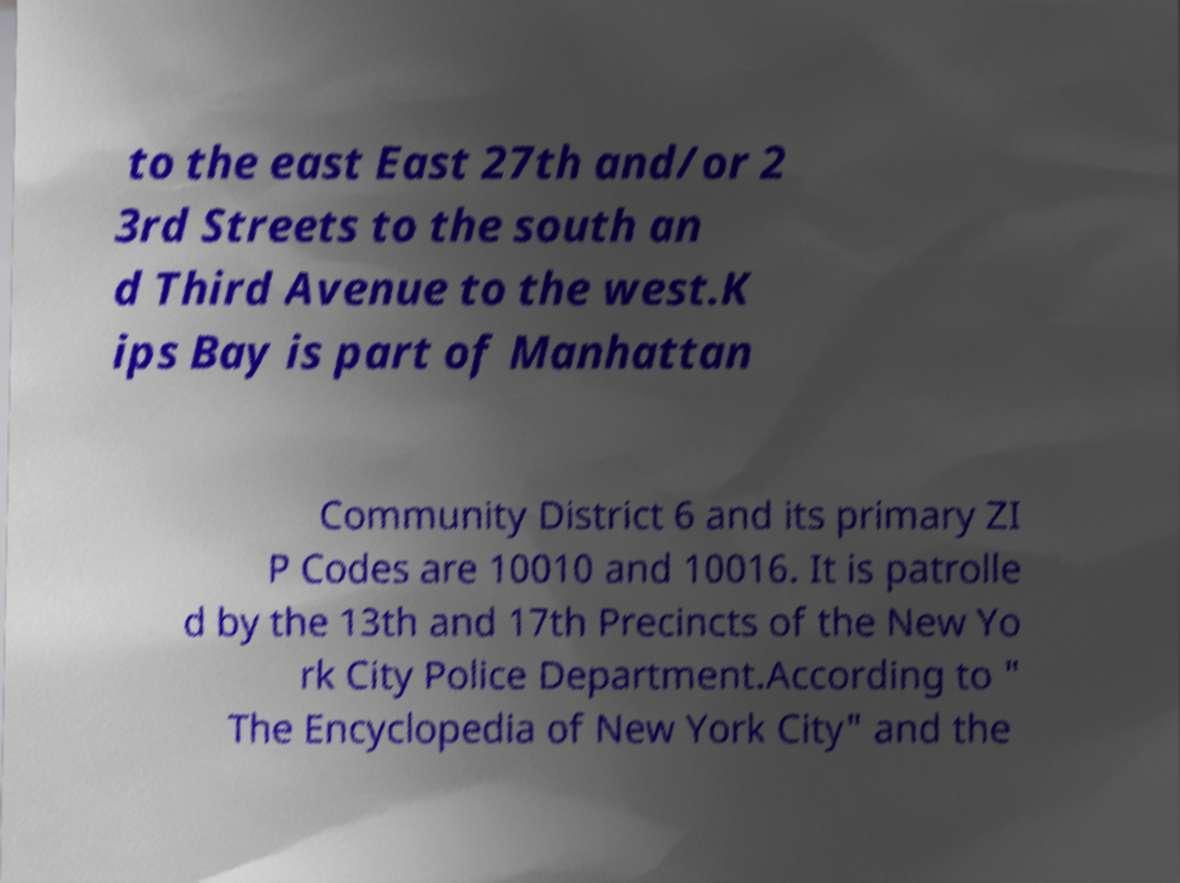I need the written content from this picture converted into text. Can you do that? to the east East 27th and/or 2 3rd Streets to the south an d Third Avenue to the west.K ips Bay is part of Manhattan Community District 6 and its primary ZI P Codes are 10010 and 10016. It is patrolle d by the 13th and 17th Precincts of the New Yo rk City Police Department.According to " The Encyclopedia of New York City" and the 